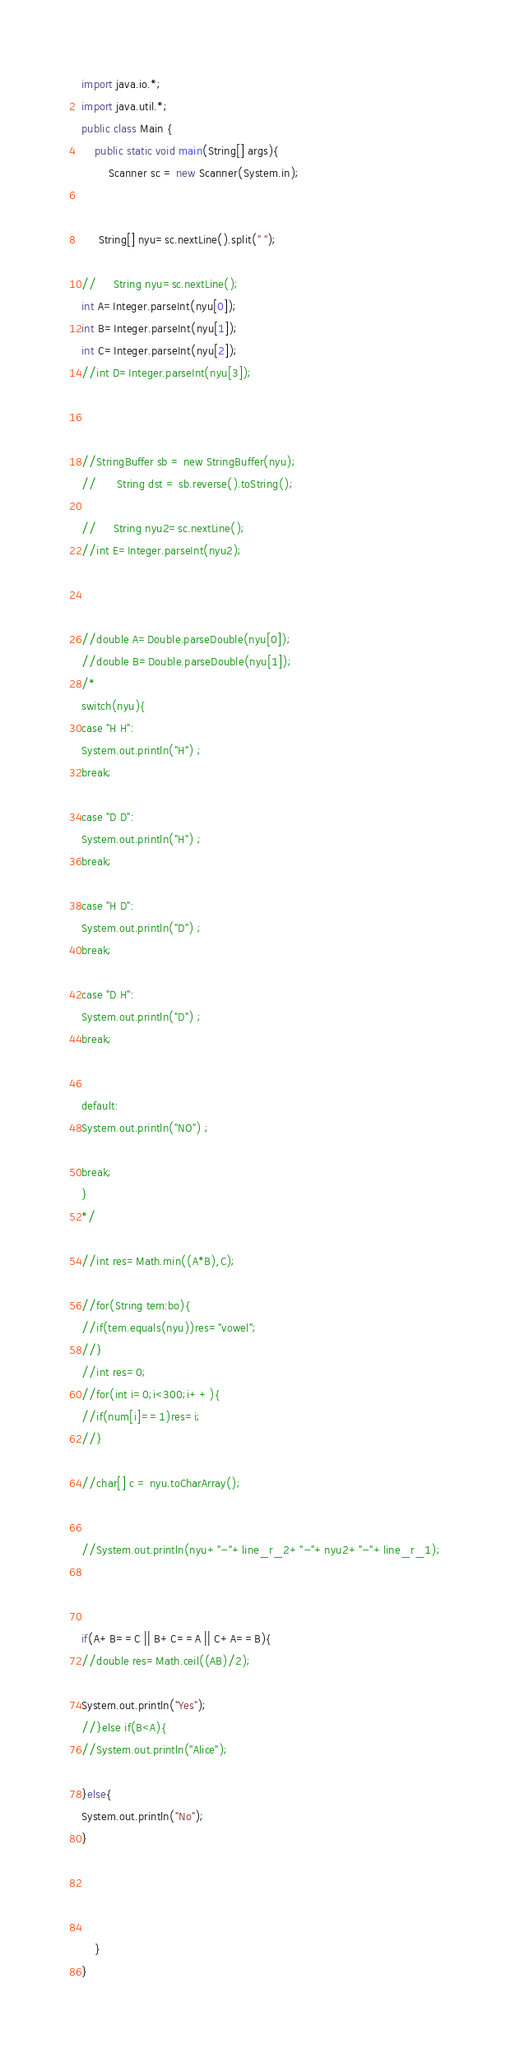<code> <loc_0><loc_0><loc_500><loc_500><_Java_>import java.io.*;
import java.util.*;
public class Main {
	public static void main(String[] args){
		Scanner sc = new Scanner(System.in);
 

     String[] nyu=sc.nextLine().split(" ");

//     String nyu=sc.nextLine();
int A=Integer.parseInt(nyu[0]);
int B=Integer.parseInt(nyu[1]);
int C=Integer.parseInt(nyu[2]);
//int D=Integer.parseInt(nyu[3]);



//StringBuffer sb = new StringBuffer(nyu);
//		String dst = sb.reverse().toString();

//     String nyu2=sc.nextLine();
//int E=Integer.parseInt(nyu2);



//double A=Double.parseDouble(nyu[0]);
//double B=Double.parseDouble(nyu[1]);
/*
switch(nyu){
case "H H":
System.out.println("H") ;
break;

case "D D":
System.out.println("H") ;
break;

case "H D":
System.out.println("D") ;
break;

case "D H":
System.out.println("D") ;
break;


default:
System.out.println("NO") ;

break;
}
*/

//int res=Math.min((A*B),C);

//for(String tem:bo){
//if(tem.equals(nyu))res="vowel";
//}
//int res=0;
//for(int i=0;i<300;i++){
//if(num[i]==1)res=i;
//}

//char[] c = nyu.toCharArray();


//System.out.println(nyu+"-"+line_r_2+"-"+nyu2+"-"+line_r_1);



if(A+B==C || B+C==A || C+A==B){
//double res=Math.ceil((AB)/2);

System.out.println("Yes");
//}else if(B<A){
//System.out.println("Alice");

}else{
System.out.println("No");
}




	}
}</code> 